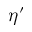Convert formula to latex. <formula><loc_0><loc_0><loc_500><loc_500>\eta ^ { \prime }</formula> 